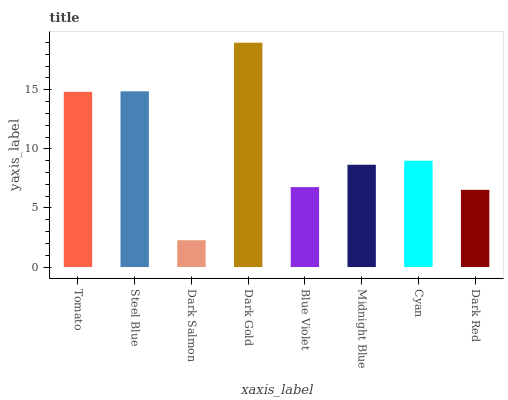Is Dark Salmon the minimum?
Answer yes or no. Yes. Is Dark Gold the maximum?
Answer yes or no. Yes. Is Steel Blue the minimum?
Answer yes or no. No. Is Steel Blue the maximum?
Answer yes or no. No. Is Steel Blue greater than Tomato?
Answer yes or no. Yes. Is Tomato less than Steel Blue?
Answer yes or no. Yes. Is Tomato greater than Steel Blue?
Answer yes or no. No. Is Steel Blue less than Tomato?
Answer yes or no. No. Is Cyan the high median?
Answer yes or no. Yes. Is Midnight Blue the low median?
Answer yes or no. Yes. Is Dark Red the high median?
Answer yes or no. No. Is Cyan the low median?
Answer yes or no. No. 